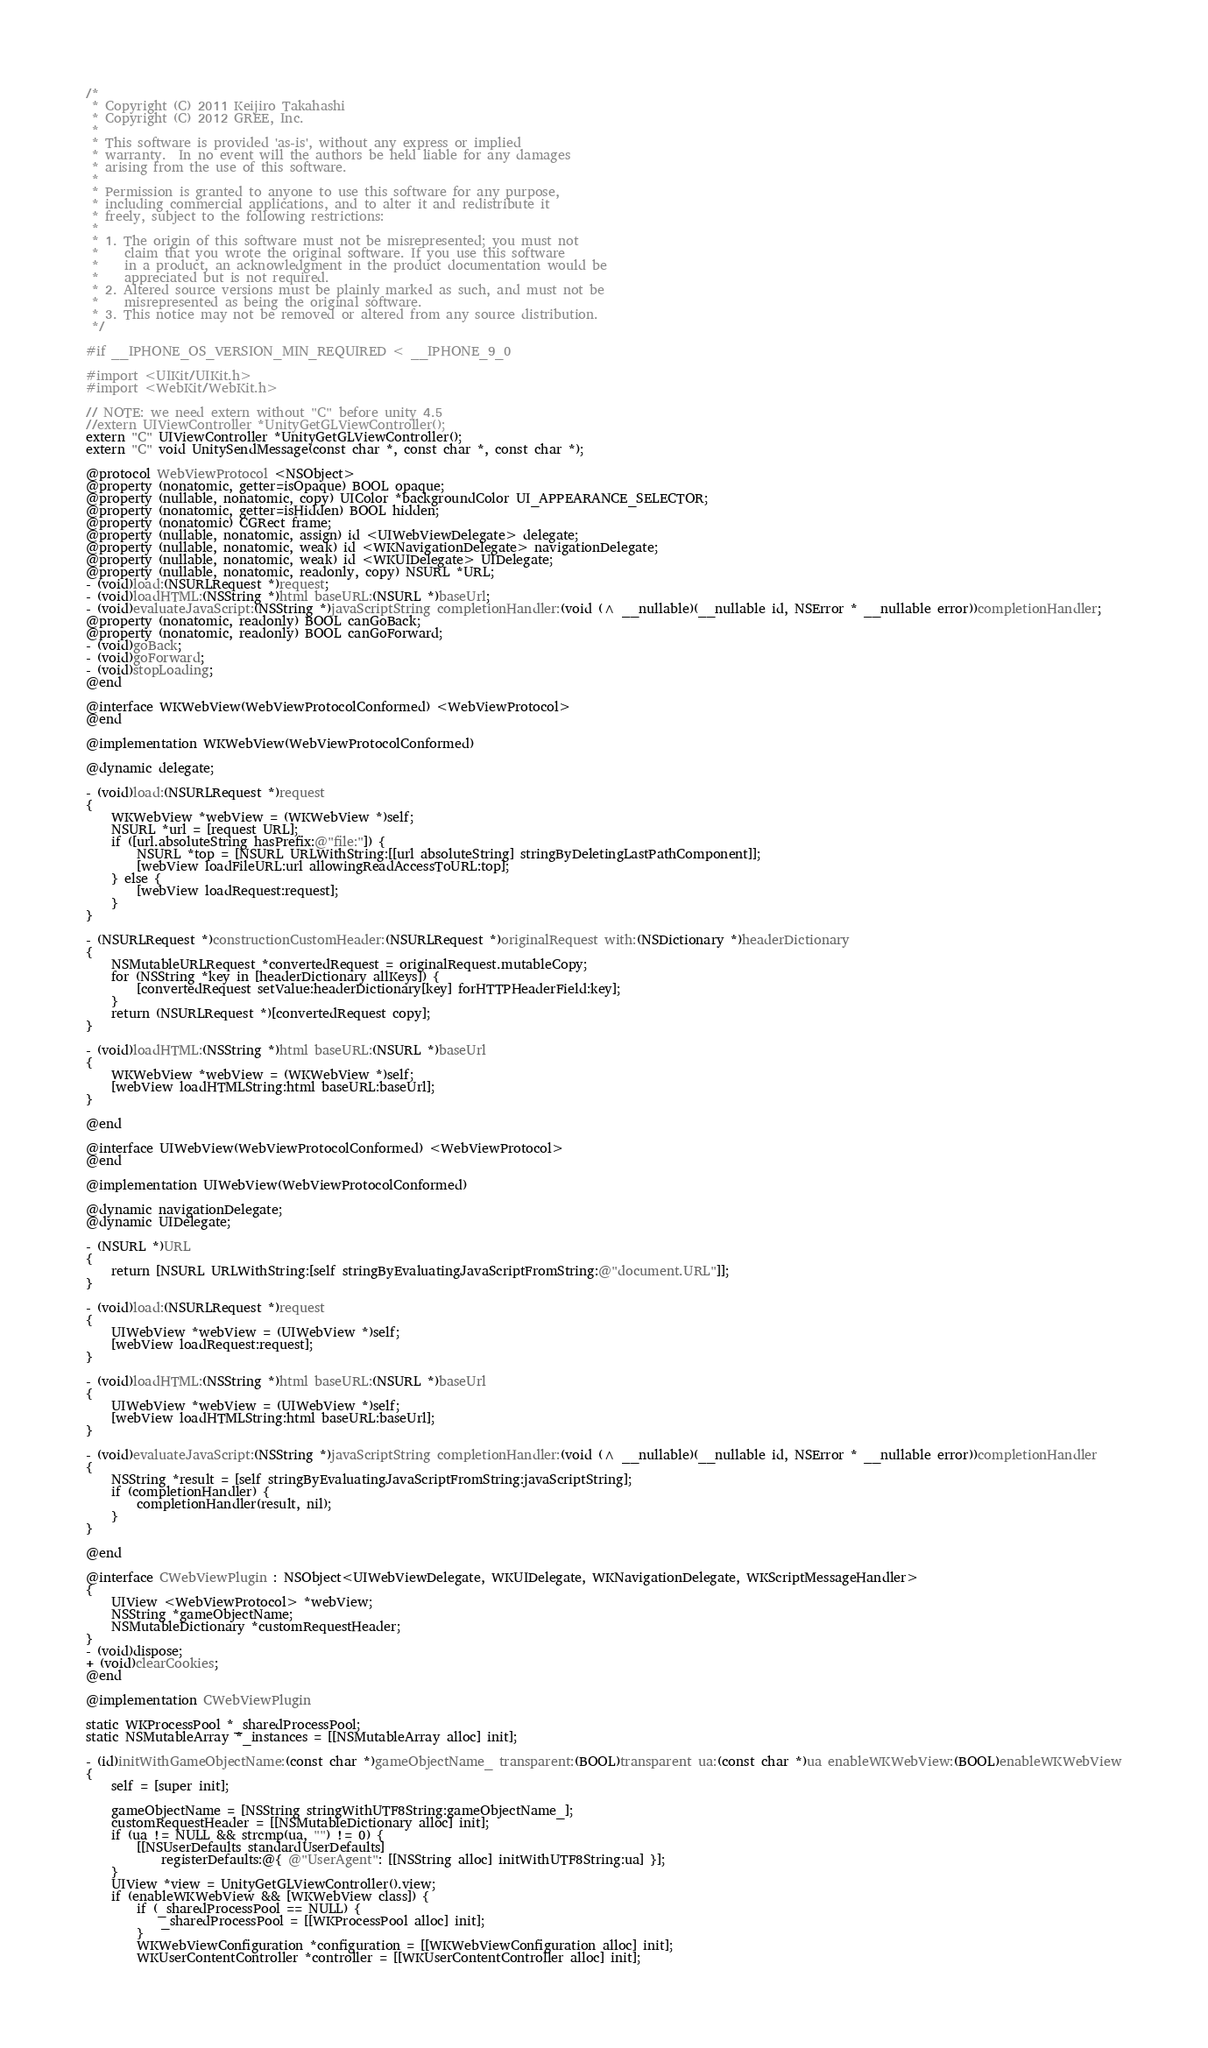<code> <loc_0><loc_0><loc_500><loc_500><_ObjectiveC_>/*
 * Copyright (C) 2011 Keijiro Takahashi
 * Copyright (C) 2012 GREE, Inc.
 *
 * This software is provided 'as-is', without any express or implied
 * warranty.  In no event will the authors be held liable for any damages
 * arising from the use of this software.
 *
 * Permission is granted to anyone to use this software for any purpose,
 * including commercial applications, and to alter it and redistribute it
 * freely, subject to the following restrictions:
 *
 * 1. The origin of this software must not be misrepresented; you must not
 *    claim that you wrote the original software. If you use this software
 *    in a product, an acknowledgment in the product documentation would be
 *    appreciated but is not required.
 * 2. Altered source versions must be plainly marked as such, and must not be
 *    misrepresented as being the original software.
 * 3. This notice may not be removed or altered from any source distribution.
 */

#if __IPHONE_OS_VERSION_MIN_REQUIRED < __IPHONE_9_0

#import <UIKit/UIKit.h>
#import <WebKit/WebKit.h>

// NOTE: we need extern without "C" before unity 4.5
//extern UIViewController *UnityGetGLViewController();
extern "C" UIViewController *UnityGetGLViewController();
extern "C" void UnitySendMessage(const char *, const char *, const char *);

@protocol WebViewProtocol <NSObject>
@property (nonatomic, getter=isOpaque) BOOL opaque;
@property (nullable, nonatomic, copy) UIColor *backgroundColor UI_APPEARANCE_SELECTOR;
@property (nonatomic, getter=isHidden) BOOL hidden;
@property (nonatomic) CGRect frame;
@property (nullable, nonatomic, assign) id <UIWebViewDelegate> delegate;
@property (nullable, nonatomic, weak) id <WKNavigationDelegate> navigationDelegate;
@property (nullable, nonatomic, weak) id <WKUIDelegate> UIDelegate;
@property (nullable, nonatomic, readonly, copy) NSURL *URL;
- (void)load:(NSURLRequest *)request;
- (void)loadHTML:(NSString *)html baseURL:(NSURL *)baseUrl;
- (void)evaluateJavaScript:(NSString *)javaScriptString completionHandler:(void (^ __nullable)(__nullable id, NSError * __nullable error))completionHandler;
@property (nonatomic, readonly) BOOL canGoBack;
@property (nonatomic, readonly) BOOL canGoForward;
- (void)goBack;
- (void)goForward;
- (void)stopLoading;
@end

@interface WKWebView(WebViewProtocolConformed) <WebViewProtocol>
@end

@implementation WKWebView(WebViewProtocolConformed)

@dynamic delegate;

- (void)load:(NSURLRequest *)request
{
    WKWebView *webView = (WKWebView *)self;
    NSURL *url = [request URL];
    if ([url.absoluteString hasPrefix:@"file:"]) {
        NSURL *top = [NSURL URLWithString:[[url absoluteString] stringByDeletingLastPathComponent]];
        [webView loadFileURL:url allowingReadAccessToURL:top];
    } else {
        [webView loadRequest:request];
    }
}

- (NSURLRequest *)constructionCustomHeader:(NSURLRequest *)originalRequest with:(NSDictionary *)headerDictionary
{
    NSMutableURLRequest *convertedRequest = originalRequest.mutableCopy;
    for (NSString *key in [headerDictionary allKeys]) {
        [convertedRequest setValue:headerDictionary[key] forHTTPHeaderField:key];
    }
    return (NSURLRequest *)[convertedRequest copy];
}

- (void)loadHTML:(NSString *)html baseURL:(NSURL *)baseUrl
{
    WKWebView *webView = (WKWebView *)self;
    [webView loadHTMLString:html baseURL:baseUrl];
}

@end

@interface UIWebView(WebViewProtocolConformed) <WebViewProtocol>
@end

@implementation UIWebView(WebViewProtocolConformed)

@dynamic navigationDelegate;
@dynamic UIDelegate;

- (NSURL *)URL
{
    return [NSURL URLWithString:[self stringByEvaluatingJavaScriptFromString:@"document.URL"]];
}

- (void)load:(NSURLRequest *)request
{
    UIWebView *webView = (UIWebView *)self;
    [webView loadRequest:request];
}

- (void)loadHTML:(NSString *)html baseURL:(NSURL *)baseUrl
{
    UIWebView *webView = (UIWebView *)self;
    [webView loadHTMLString:html baseURL:baseUrl];
}

- (void)evaluateJavaScript:(NSString *)javaScriptString completionHandler:(void (^ __nullable)(__nullable id, NSError * __nullable error))completionHandler
{
    NSString *result = [self stringByEvaluatingJavaScriptFromString:javaScriptString];
    if (completionHandler) {
        completionHandler(result, nil);
    }
}

@end

@interface CWebViewPlugin : NSObject<UIWebViewDelegate, WKUIDelegate, WKNavigationDelegate, WKScriptMessageHandler>
{
    UIView <WebViewProtocol> *webView;
    NSString *gameObjectName;
    NSMutableDictionary *customRequestHeader;
}
- (void)dispose;
+ (void)clearCookies;
@end

@implementation CWebViewPlugin

static WKProcessPool *_sharedProcessPool;
static NSMutableArray *_instances = [[NSMutableArray alloc] init];

- (id)initWithGameObjectName:(const char *)gameObjectName_ transparent:(BOOL)transparent ua:(const char *)ua enableWKWebView:(BOOL)enableWKWebView
{
    self = [super init];

    gameObjectName = [NSString stringWithUTF8String:gameObjectName_];
    customRequestHeader = [[NSMutableDictionary alloc] init];
    if (ua != NULL && strcmp(ua, "") != 0) {
        [[NSUserDefaults standardUserDefaults]
            registerDefaults:@{ @"UserAgent": [[NSString alloc] initWithUTF8String:ua] }];
    }
    UIView *view = UnityGetGLViewController().view;
    if (enableWKWebView && [WKWebView class]) {
        if (_sharedProcessPool == NULL) {
            _sharedProcessPool = [[WKProcessPool alloc] init];
        }
        WKWebViewConfiguration *configuration = [[WKWebViewConfiguration alloc] init];
        WKUserContentController *controller = [[WKUserContentController alloc] init];</code> 